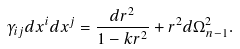<formula> <loc_0><loc_0><loc_500><loc_500>\gamma _ { i j } d x ^ { i } d x ^ { j } = \frac { d r ^ { 2 } } { 1 - k r ^ { 2 } } + r ^ { 2 } d \Omega ^ { 2 } _ { n - 1 } .</formula> 